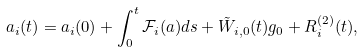<formula> <loc_0><loc_0><loc_500><loc_500>a _ { i } ( t ) = a _ { i } ( 0 ) + \int _ { 0 } ^ { t } \mathcal { F } _ { i } ( a ) d s + \tilde { W } _ { i , 0 } ( t ) g _ { 0 } + R _ { i } ^ { ( 2 ) } ( t ) ,</formula> 